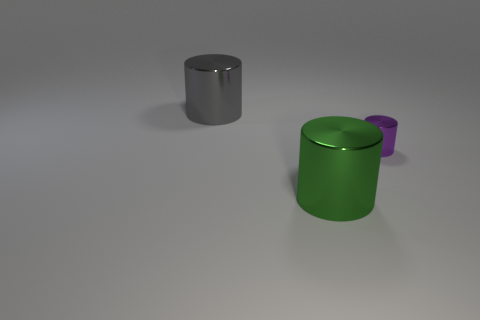What number of cylinders are both to the left of the tiny purple metallic object and in front of the big gray cylinder?
Your answer should be compact. 1. Is the number of tiny purple metal things greater than the number of tiny blocks?
Make the answer very short. Yes. How many other things are there of the same shape as the green metal object?
Your answer should be very brief. 2. What is the thing that is both to the left of the tiny cylinder and behind the green cylinder made of?
Make the answer very short. Metal. What is the size of the purple cylinder?
Provide a succinct answer. Small. There is a big shiny object that is right of the cylinder that is on the left side of the big green metallic cylinder; what number of cylinders are to the right of it?
Give a very brief answer. 1. There is a purple thing that is the same shape as the big gray metallic thing; what size is it?
Your response must be concise. Small. Is there anything else that is the same size as the gray cylinder?
Your answer should be very brief. Yes. What is the color of the big metallic object to the left of the large green object?
Offer a very short reply. Gray. There is a large cylinder right of the big thing that is behind the cylinder that is on the right side of the green metal object; what is it made of?
Ensure brevity in your answer.  Metal. 